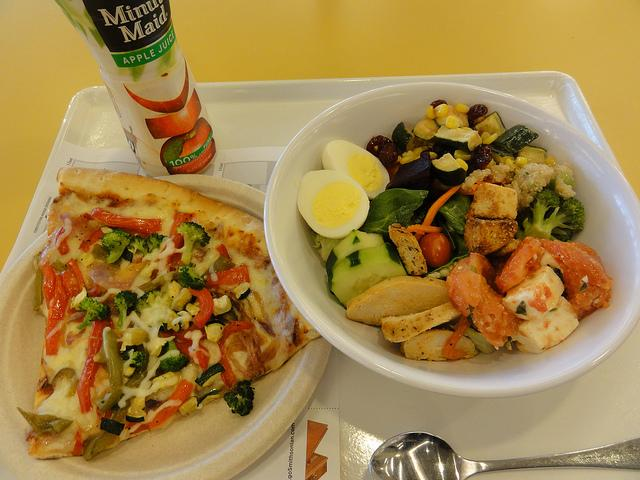What type of red sliced topping is on the pizza?

Choices:
A) pepper
B) olive
C) pepperoni
D) mushroom pepper 